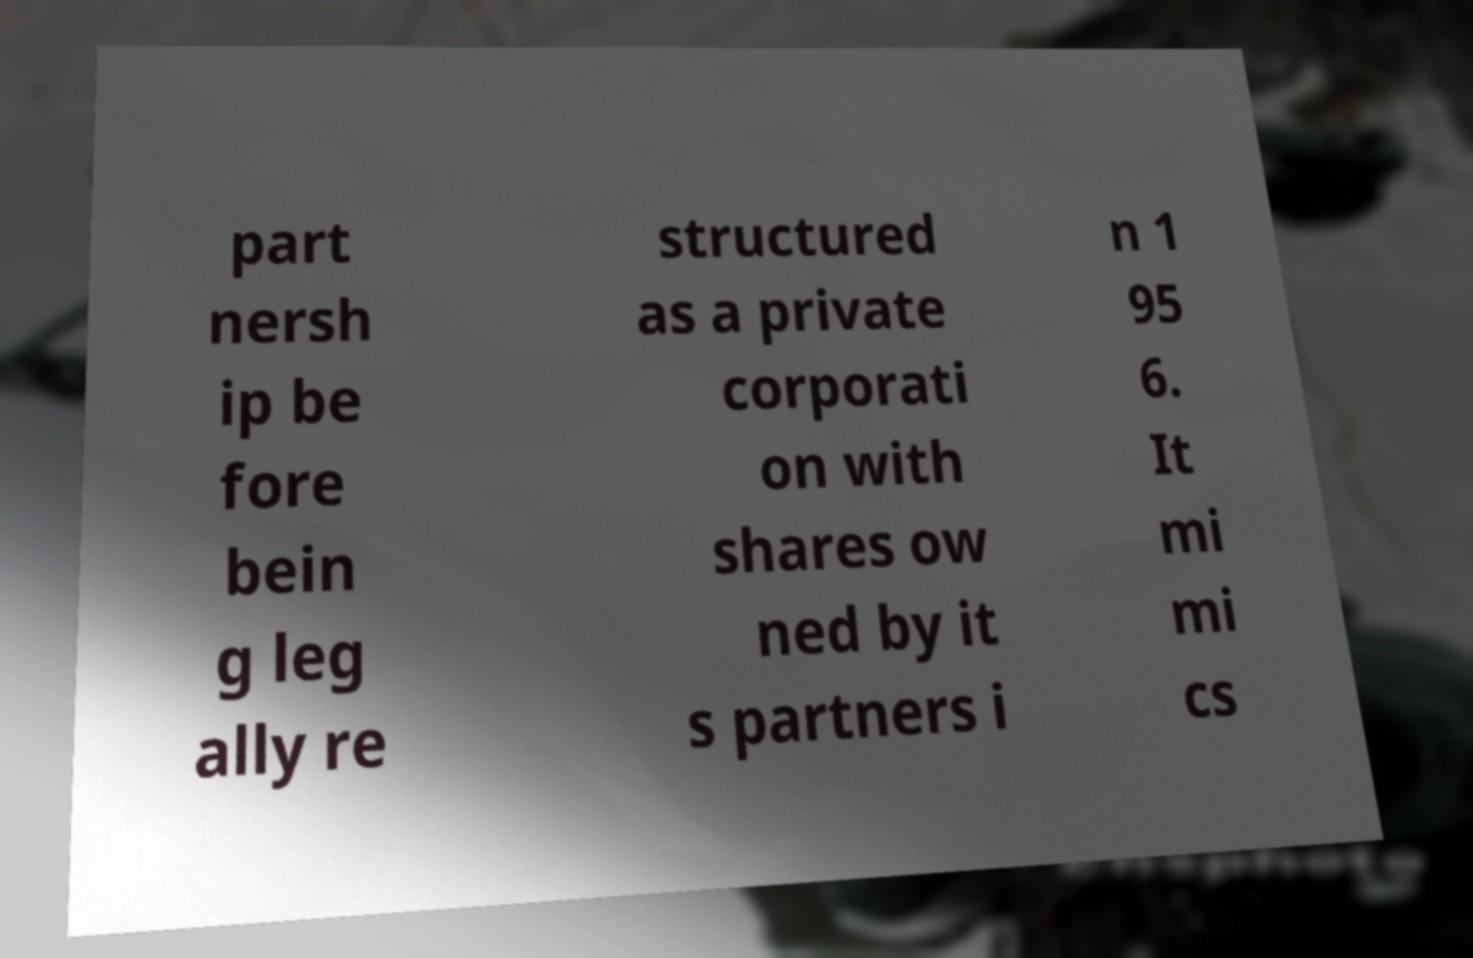Could you extract and type out the text from this image? part nersh ip be fore bein g leg ally re structured as a private corporati on with shares ow ned by it s partners i n 1 95 6. It mi mi cs 